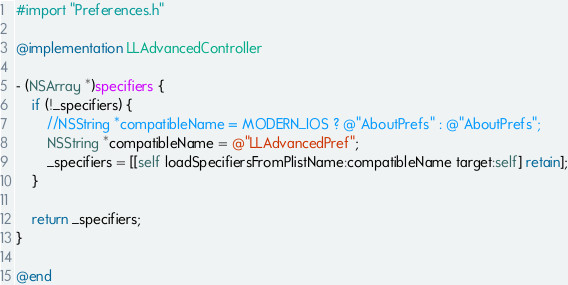<code> <loc_0><loc_0><loc_500><loc_500><_ObjectiveC_>#import "Preferences.h"

@implementation LLAdvancedController

- (NSArray *)specifiers {
	if (!_specifiers) {
		//NSString *compatibleName = MODERN_IOS ? @"AboutPrefs" : @"AboutPrefs";
		NSString *compatibleName = @"LLAdvancedPref";
		_specifiers = [[self loadSpecifiersFromPlistName:compatibleName target:self] retain];
	}

	return _specifiers;
}

@end</code> 